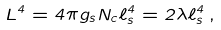<formula> <loc_0><loc_0><loc_500><loc_500>L ^ { 4 } = 4 \pi g _ { s } N _ { c } \ell _ { s } ^ { 4 } = 2 \lambda \ell _ { s } ^ { 4 } \, ,</formula> 